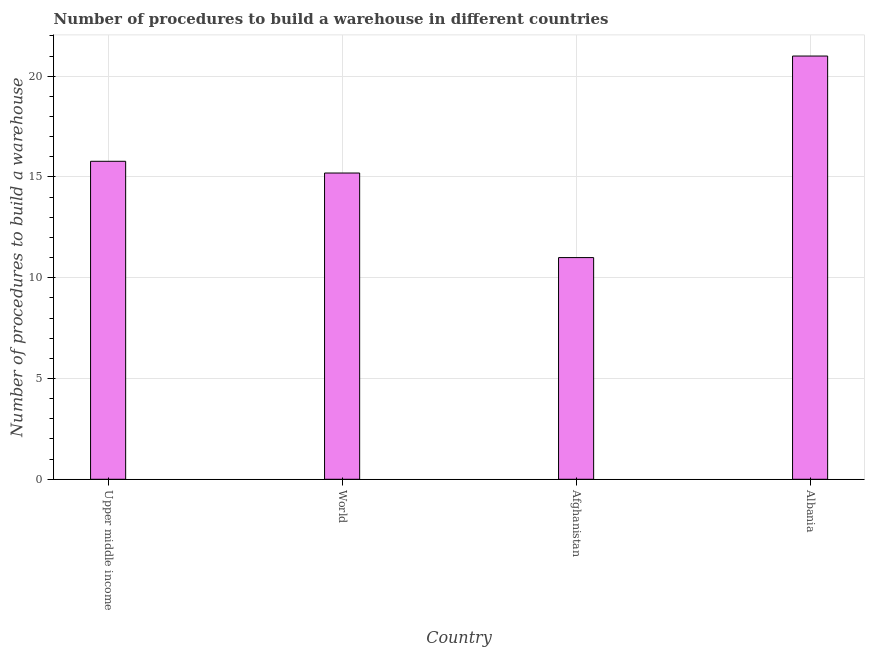Does the graph contain any zero values?
Ensure brevity in your answer.  No. What is the title of the graph?
Your response must be concise. Number of procedures to build a warehouse in different countries. What is the label or title of the X-axis?
Provide a short and direct response. Country. What is the label or title of the Y-axis?
Provide a short and direct response. Number of procedures to build a warehouse. What is the number of procedures to build a warehouse in Upper middle income?
Provide a short and direct response. 15.78. Across all countries, what is the maximum number of procedures to build a warehouse?
Keep it short and to the point. 21. Across all countries, what is the minimum number of procedures to build a warehouse?
Offer a terse response. 11. In which country was the number of procedures to build a warehouse maximum?
Ensure brevity in your answer.  Albania. In which country was the number of procedures to build a warehouse minimum?
Make the answer very short. Afghanistan. What is the sum of the number of procedures to build a warehouse?
Give a very brief answer. 62.97. What is the difference between the number of procedures to build a warehouse in Albania and Upper middle income?
Give a very brief answer. 5.22. What is the average number of procedures to build a warehouse per country?
Your response must be concise. 15.74. What is the median number of procedures to build a warehouse?
Offer a terse response. 15.49. What is the ratio of the number of procedures to build a warehouse in Upper middle income to that in World?
Provide a short and direct response. 1.04. What is the difference between the highest and the second highest number of procedures to build a warehouse?
Ensure brevity in your answer.  5.22. Is the sum of the number of procedures to build a warehouse in Afghanistan and Albania greater than the maximum number of procedures to build a warehouse across all countries?
Your answer should be very brief. Yes. What is the difference between the highest and the lowest number of procedures to build a warehouse?
Your answer should be compact. 10. How many countries are there in the graph?
Make the answer very short. 4. What is the difference between two consecutive major ticks on the Y-axis?
Offer a terse response. 5. Are the values on the major ticks of Y-axis written in scientific E-notation?
Provide a succinct answer. No. What is the Number of procedures to build a warehouse of Upper middle income?
Offer a very short reply. 15.78. What is the Number of procedures to build a warehouse in World?
Provide a short and direct response. 15.2. What is the Number of procedures to build a warehouse of Afghanistan?
Offer a terse response. 11. What is the difference between the Number of procedures to build a warehouse in Upper middle income and World?
Make the answer very short. 0.58. What is the difference between the Number of procedures to build a warehouse in Upper middle income and Afghanistan?
Keep it short and to the point. 4.78. What is the difference between the Number of procedures to build a warehouse in Upper middle income and Albania?
Your answer should be compact. -5.22. What is the difference between the Number of procedures to build a warehouse in World and Afghanistan?
Provide a succinct answer. 4.2. What is the difference between the Number of procedures to build a warehouse in World and Albania?
Your answer should be very brief. -5.8. What is the ratio of the Number of procedures to build a warehouse in Upper middle income to that in World?
Ensure brevity in your answer.  1.04. What is the ratio of the Number of procedures to build a warehouse in Upper middle income to that in Afghanistan?
Your answer should be very brief. 1.43. What is the ratio of the Number of procedures to build a warehouse in Upper middle income to that in Albania?
Make the answer very short. 0.75. What is the ratio of the Number of procedures to build a warehouse in World to that in Afghanistan?
Give a very brief answer. 1.38. What is the ratio of the Number of procedures to build a warehouse in World to that in Albania?
Make the answer very short. 0.72. What is the ratio of the Number of procedures to build a warehouse in Afghanistan to that in Albania?
Your answer should be very brief. 0.52. 